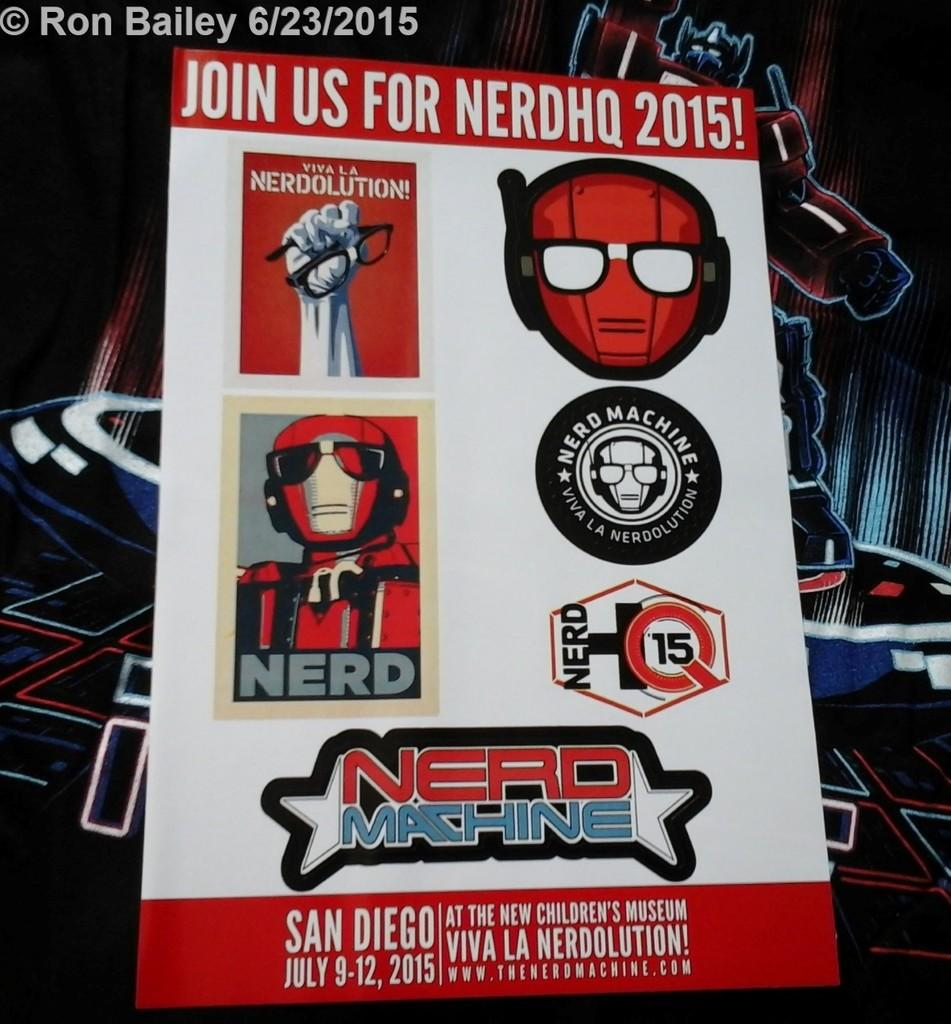<image>
Share a concise interpretation of the image provided. A Nerd Machine poster advertises a convention in San Diego. 